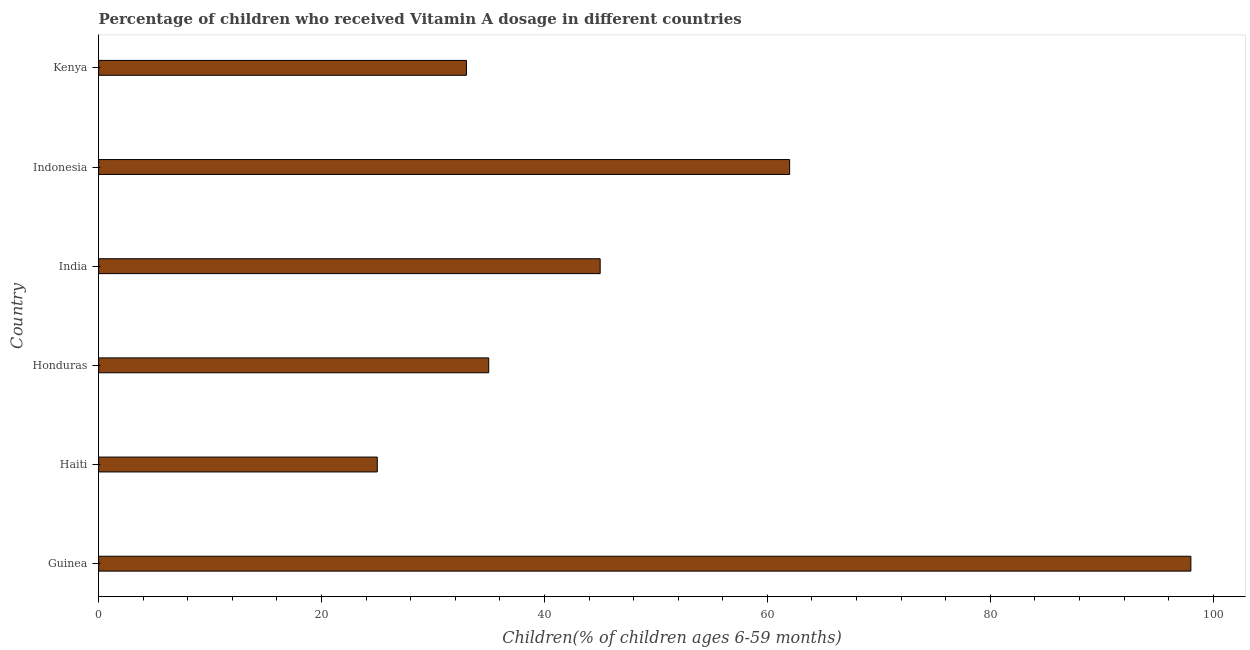Does the graph contain grids?
Make the answer very short. No. What is the title of the graph?
Offer a very short reply. Percentage of children who received Vitamin A dosage in different countries. What is the label or title of the X-axis?
Provide a succinct answer. Children(% of children ages 6-59 months). What is the label or title of the Y-axis?
Give a very brief answer. Country. Across all countries, what is the maximum vitamin a supplementation coverage rate?
Offer a terse response. 98. In which country was the vitamin a supplementation coverage rate maximum?
Your response must be concise. Guinea. In which country was the vitamin a supplementation coverage rate minimum?
Give a very brief answer. Haiti. What is the sum of the vitamin a supplementation coverage rate?
Your answer should be compact. 298. What is the difference between the vitamin a supplementation coverage rate in Honduras and Kenya?
Your answer should be very brief. 2. What is the average vitamin a supplementation coverage rate per country?
Provide a succinct answer. 49.67. What is the ratio of the vitamin a supplementation coverage rate in India to that in Kenya?
Your response must be concise. 1.36. Is the vitamin a supplementation coverage rate in Guinea less than that in Indonesia?
Offer a very short reply. No. In how many countries, is the vitamin a supplementation coverage rate greater than the average vitamin a supplementation coverage rate taken over all countries?
Offer a very short reply. 2. Are all the bars in the graph horizontal?
Offer a very short reply. Yes. How many countries are there in the graph?
Keep it short and to the point. 6. What is the Children(% of children ages 6-59 months) in Guinea?
Provide a short and direct response. 98. What is the Children(% of children ages 6-59 months) of Haiti?
Give a very brief answer. 25. What is the Children(% of children ages 6-59 months) in Honduras?
Ensure brevity in your answer.  35. What is the Children(% of children ages 6-59 months) of India?
Your answer should be very brief. 45. What is the difference between the Children(% of children ages 6-59 months) in Guinea and Honduras?
Offer a very short reply. 63. What is the difference between the Children(% of children ages 6-59 months) in Guinea and India?
Your answer should be very brief. 53. What is the difference between the Children(% of children ages 6-59 months) in Guinea and Indonesia?
Your answer should be very brief. 36. What is the difference between the Children(% of children ages 6-59 months) in Guinea and Kenya?
Give a very brief answer. 65. What is the difference between the Children(% of children ages 6-59 months) in Haiti and Indonesia?
Give a very brief answer. -37. What is the difference between the Children(% of children ages 6-59 months) in Haiti and Kenya?
Make the answer very short. -8. What is the difference between the Children(% of children ages 6-59 months) in Honduras and Kenya?
Your answer should be compact. 2. What is the difference between the Children(% of children ages 6-59 months) in India and Kenya?
Provide a short and direct response. 12. What is the ratio of the Children(% of children ages 6-59 months) in Guinea to that in Haiti?
Your answer should be very brief. 3.92. What is the ratio of the Children(% of children ages 6-59 months) in Guinea to that in India?
Give a very brief answer. 2.18. What is the ratio of the Children(% of children ages 6-59 months) in Guinea to that in Indonesia?
Offer a terse response. 1.58. What is the ratio of the Children(% of children ages 6-59 months) in Guinea to that in Kenya?
Keep it short and to the point. 2.97. What is the ratio of the Children(% of children ages 6-59 months) in Haiti to that in Honduras?
Your response must be concise. 0.71. What is the ratio of the Children(% of children ages 6-59 months) in Haiti to that in India?
Your answer should be compact. 0.56. What is the ratio of the Children(% of children ages 6-59 months) in Haiti to that in Indonesia?
Provide a short and direct response. 0.4. What is the ratio of the Children(% of children ages 6-59 months) in Haiti to that in Kenya?
Provide a succinct answer. 0.76. What is the ratio of the Children(% of children ages 6-59 months) in Honduras to that in India?
Make the answer very short. 0.78. What is the ratio of the Children(% of children ages 6-59 months) in Honduras to that in Indonesia?
Give a very brief answer. 0.56. What is the ratio of the Children(% of children ages 6-59 months) in Honduras to that in Kenya?
Make the answer very short. 1.06. What is the ratio of the Children(% of children ages 6-59 months) in India to that in Indonesia?
Provide a succinct answer. 0.73. What is the ratio of the Children(% of children ages 6-59 months) in India to that in Kenya?
Your answer should be compact. 1.36. What is the ratio of the Children(% of children ages 6-59 months) in Indonesia to that in Kenya?
Provide a succinct answer. 1.88. 